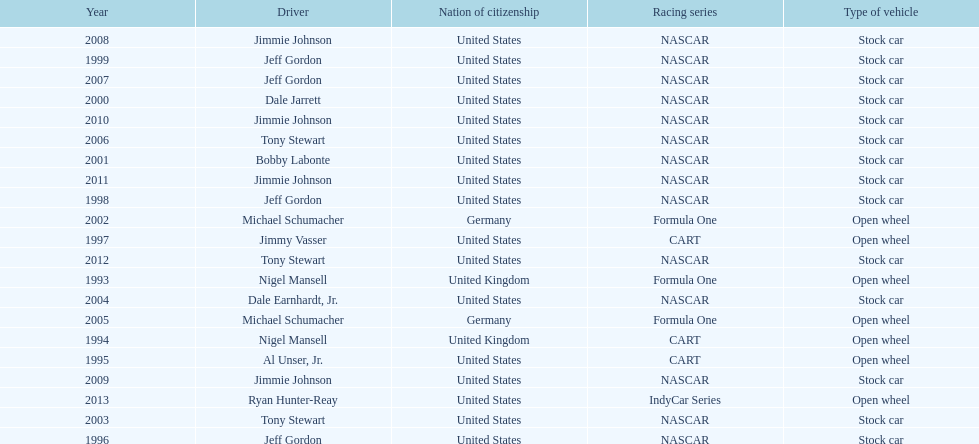Besides nascar, what other racing series have espy-winning drivers come from? Formula One, CART, IndyCar Series. 